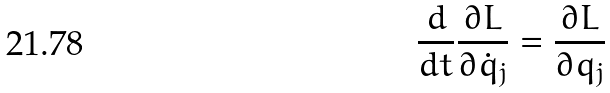Convert formula to latex. <formula><loc_0><loc_0><loc_500><loc_500>\frac { d } { d t } \frac { \partial L } { \partial \dot { q } _ { j } } = \frac { \partial L } { \partial q _ { j } }</formula> 